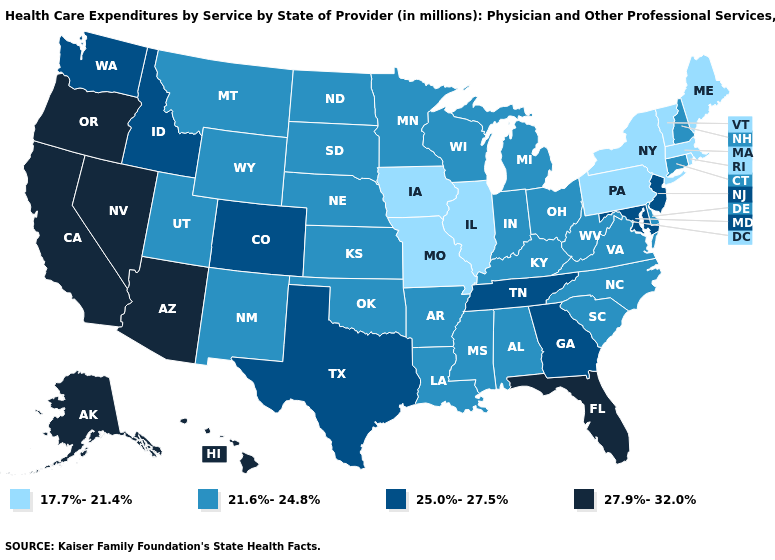What is the value of Alaska?
Keep it brief. 27.9%-32.0%. What is the lowest value in the South?
Concise answer only. 21.6%-24.8%. Does Maryland have a lower value than Washington?
Give a very brief answer. No. Among the states that border Nebraska , does Colorado have the highest value?
Short answer required. Yes. Which states hav the highest value in the MidWest?
Write a very short answer. Indiana, Kansas, Michigan, Minnesota, Nebraska, North Dakota, Ohio, South Dakota, Wisconsin. What is the value of Ohio?
Be succinct. 21.6%-24.8%. Which states hav the highest value in the MidWest?
Concise answer only. Indiana, Kansas, Michigan, Minnesota, Nebraska, North Dakota, Ohio, South Dakota, Wisconsin. Does Wyoming have the highest value in the USA?
Be succinct. No. Among the states that border Massachusetts , which have the lowest value?
Write a very short answer. New York, Rhode Island, Vermont. Does the map have missing data?
Concise answer only. No. Does the map have missing data?
Answer briefly. No. What is the value of Idaho?
Give a very brief answer. 25.0%-27.5%. What is the lowest value in the USA?
Write a very short answer. 17.7%-21.4%. Among the states that border Kansas , does Nebraska have the highest value?
Give a very brief answer. No. Does South Carolina have the lowest value in the USA?
Give a very brief answer. No. 